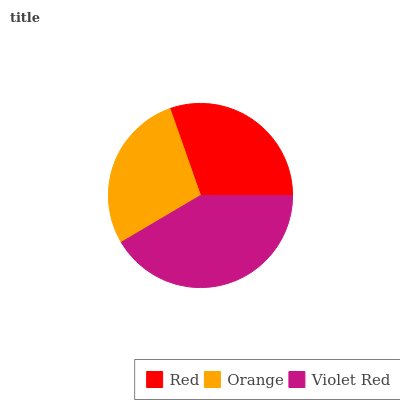Is Orange the minimum?
Answer yes or no. Yes. Is Violet Red the maximum?
Answer yes or no. Yes. Is Violet Red the minimum?
Answer yes or no. No. Is Orange the maximum?
Answer yes or no. No. Is Violet Red greater than Orange?
Answer yes or no. Yes. Is Orange less than Violet Red?
Answer yes or no. Yes. Is Orange greater than Violet Red?
Answer yes or no. No. Is Violet Red less than Orange?
Answer yes or no. No. Is Red the high median?
Answer yes or no. Yes. Is Red the low median?
Answer yes or no. Yes. Is Violet Red the high median?
Answer yes or no. No. Is Violet Red the low median?
Answer yes or no. No. 